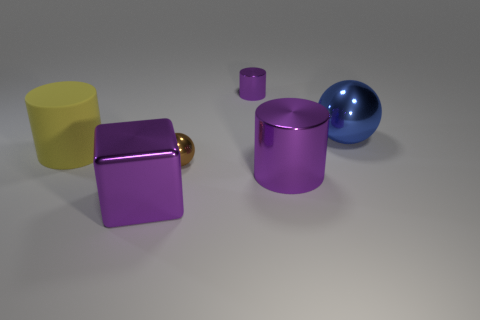Is the size of the sphere that is behind the brown sphere the same as the small brown sphere?
Your response must be concise. No. What is the shape of the tiny shiny thing that is the same color as the block?
Ensure brevity in your answer.  Cylinder. There is another cylinder that is the same color as the large metal cylinder; what is its size?
Offer a very short reply. Small. What number of other objects are there of the same color as the big cube?
Offer a very short reply. 2. Do the purple object to the right of the tiny cylinder and the tiny thing that is in front of the big blue shiny thing have the same shape?
Your answer should be very brief. No. Is the number of big shiny spheres to the left of the large yellow cylinder the same as the number of things that are on the left side of the blue metallic ball?
Offer a terse response. No. The purple metal thing behind the big cylinder behind the purple metal cylinder in front of the big blue sphere is what shape?
Make the answer very short. Cylinder. Do the purple cylinder right of the small purple object and the purple cylinder behind the yellow cylinder have the same material?
Your answer should be compact. Yes. The purple shiny thing to the left of the brown sphere has what shape?
Make the answer very short. Cube. Are there fewer yellow cylinders than big purple shiny things?
Offer a terse response. Yes. 